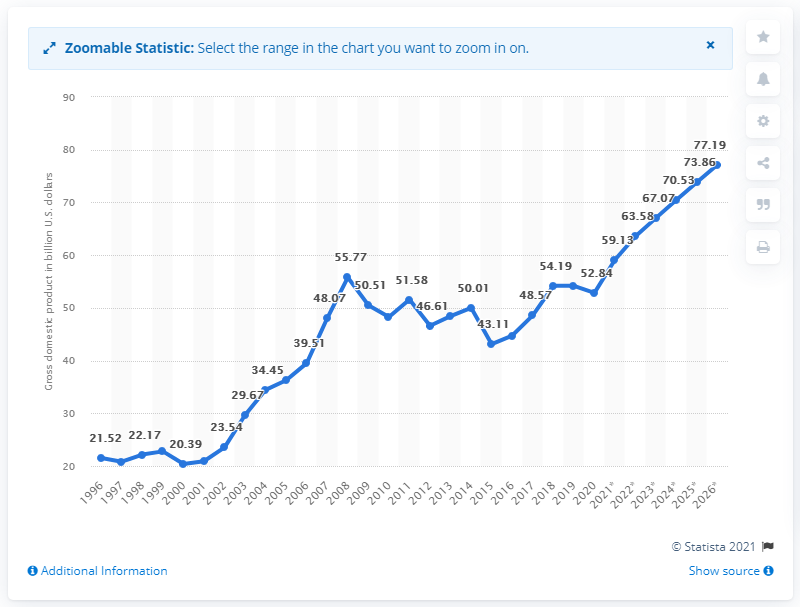Point out several critical features in this image. In 2020, Slovenia's gross domestic product was estimated to be approximately 52.84 billion dollars. 